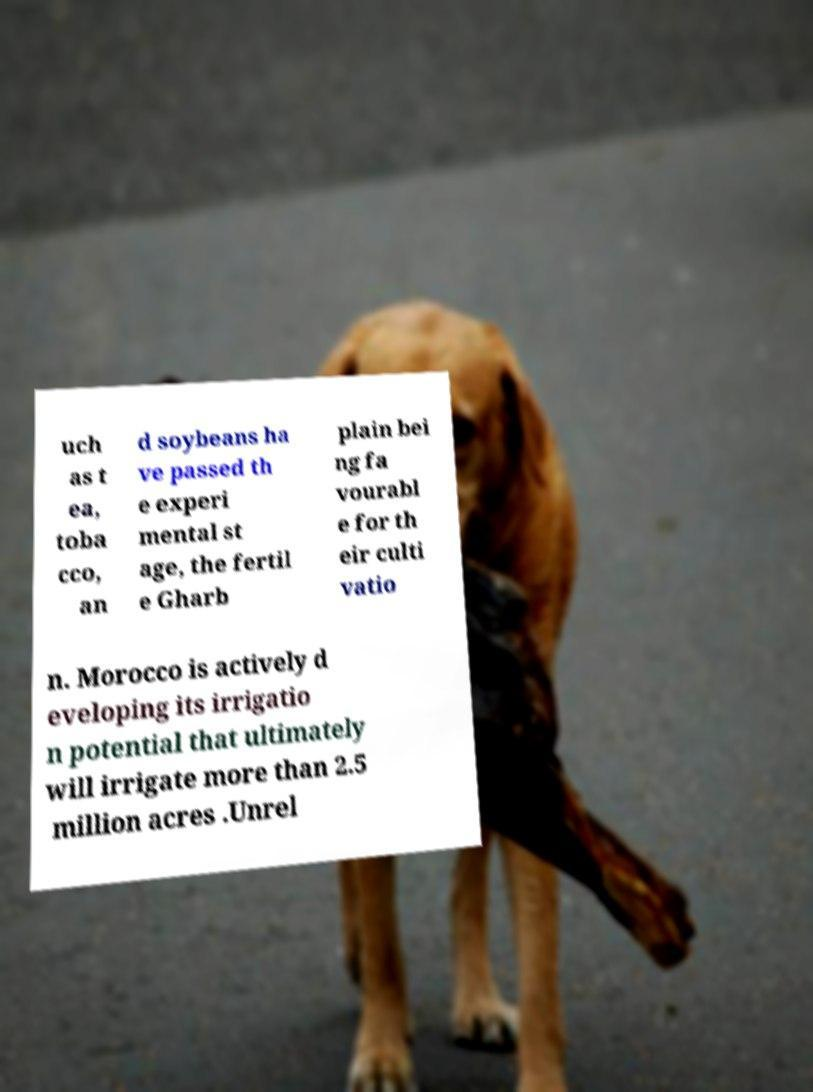Could you extract and type out the text from this image? uch as t ea, toba cco, an d soybeans ha ve passed th e experi mental st age, the fertil e Gharb plain bei ng fa vourabl e for th eir culti vatio n. Morocco is actively d eveloping its irrigatio n potential that ultimately will irrigate more than 2.5 million acres .Unrel 